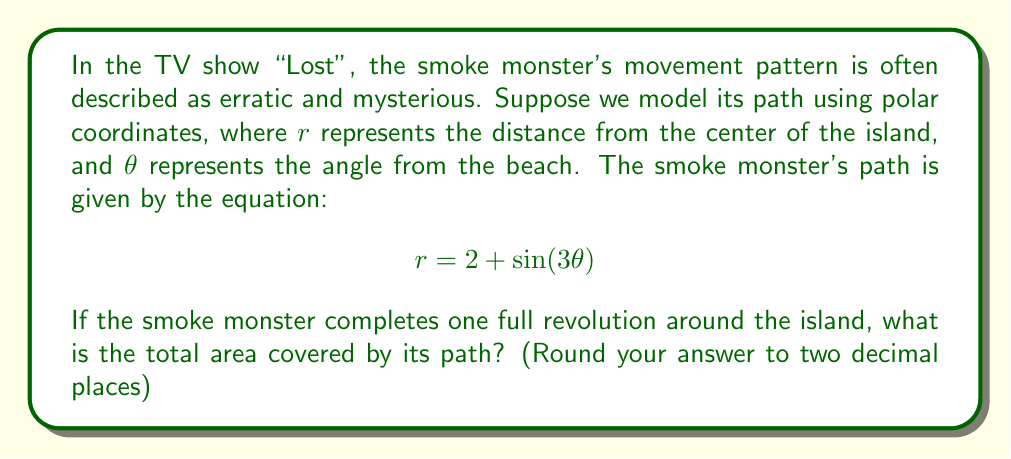What is the answer to this math problem? To solve this problem, we need to use the formula for the area enclosed by a polar curve over one complete revolution. The formula is:

$$A = \frac{1}{2} \int_0^{2\pi} r^2 d\theta$$

Let's break this down step-by-step:

1) First, we need to square our given equation for $r$:
   $$r^2 = (2 + \sin(3\theta))^2 = 4 + 4\sin(3\theta) + \sin^2(3\theta)$$

2) Now we can set up our integral:
   $$A = \frac{1}{2} \int_0^{2\pi} (4 + 4\sin(3\theta) + \sin^2(3\theta)) d\theta$$

3) Let's integrate each term separately:
   
   a) $\int_0^{2\pi} 4 d\theta = 4\theta \Big|_0^{2\pi} = 8\pi$
   
   b) $\int_0^{2\pi} 4\sin(3\theta) d\theta = -\frac{4}{3}\cos(3\theta) \Big|_0^{2\pi} = 0$
   
   c) $\int_0^{2\pi} \sin^2(3\theta) d\theta = \int_0^{2\pi} \frac{1 - \cos(6\theta)}{2} d\theta = \frac{\theta}{2} - \frac{1}{12}\sin(6\theta) \Big|_0^{2\pi} = \pi$

4) Adding these results:
   $$A = \frac{1}{2}(8\pi + 0 + \pi) = \frac{9\pi}{2} \approx 14.14$$

Therefore, the total area covered by the smoke monster's path is approximately 14.14 square units.
Answer: 14.14 square units 